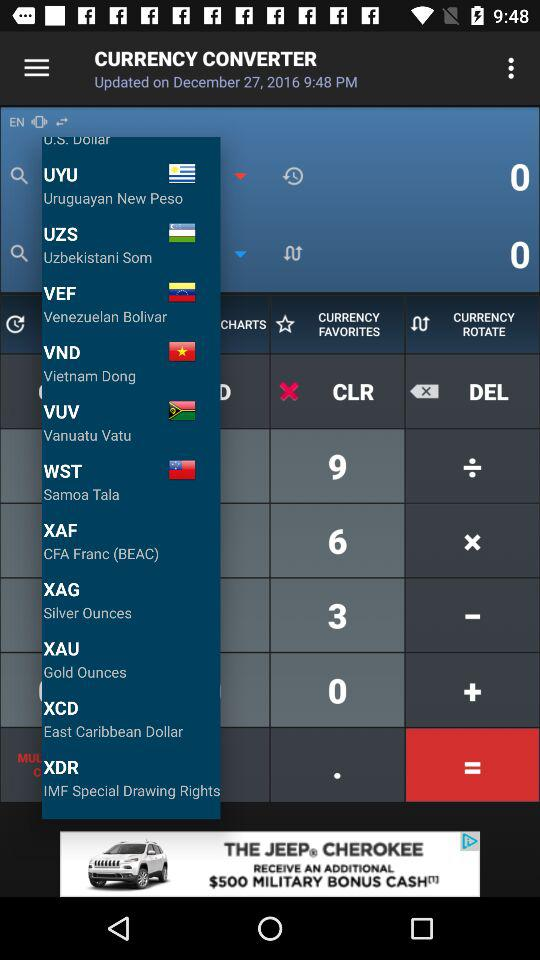When was "CURRENCY CONVERTER" updated? "CURRENCY CONVERTER" was updated on December 27, 2016 at 9:48 p.m. 